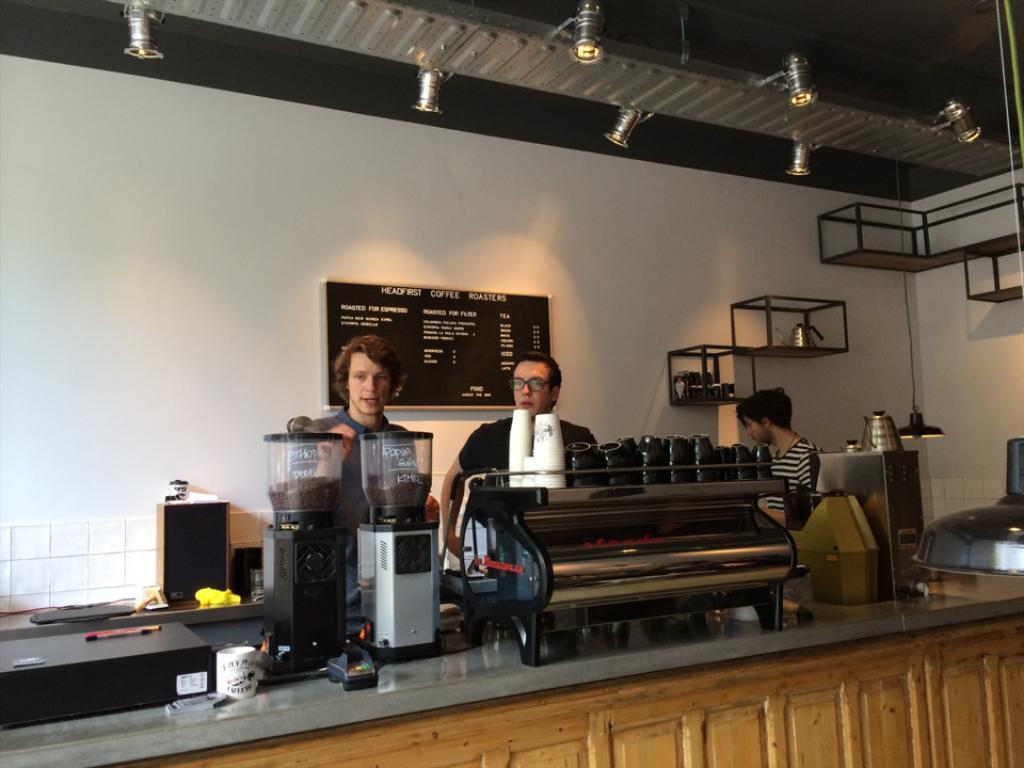<image>
Write a terse but informative summary of the picture. people behind the bar of a HEADFIRST Coffee Roasters as worded on the menu board 